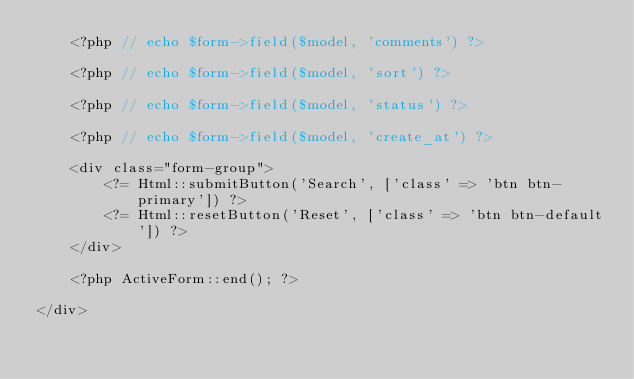Convert code to text. <code><loc_0><loc_0><loc_500><loc_500><_PHP_>    <?php // echo $form->field($model, 'comments') ?>

    <?php // echo $form->field($model, 'sort') ?>

    <?php // echo $form->field($model, 'status') ?>

    <?php // echo $form->field($model, 'create_at') ?>

    <div class="form-group">
        <?= Html::submitButton('Search', ['class' => 'btn btn-primary']) ?>
        <?= Html::resetButton('Reset', ['class' => 'btn btn-default']) ?>
    </div>

    <?php ActiveForm::end(); ?>

</div>
</code> 